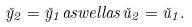Convert formula to latex. <formula><loc_0><loc_0><loc_500><loc_500>\check { y } _ { 2 } = \check { y } _ { 1 } a s w e l l a s \check { u } _ { 2 } = \check { u } _ { 1 } .</formula> 